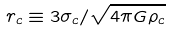<formula> <loc_0><loc_0><loc_500><loc_500>r _ { c } \equiv 3 \sigma _ { c } / \sqrt { 4 \pi G \rho _ { c } }</formula> 